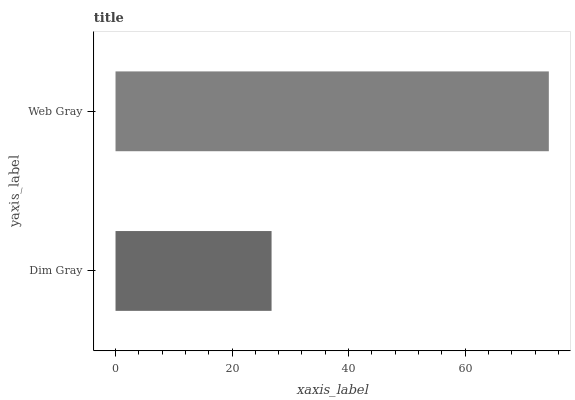Is Dim Gray the minimum?
Answer yes or no. Yes. Is Web Gray the maximum?
Answer yes or no. Yes. Is Web Gray the minimum?
Answer yes or no. No. Is Web Gray greater than Dim Gray?
Answer yes or no. Yes. Is Dim Gray less than Web Gray?
Answer yes or no. Yes. Is Dim Gray greater than Web Gray?
Answer yes or no. No. Is Web Gray less than Dim Gray?
Answer yes or no. No. Is Web Gray the high median?
Answer yes or no. Yes. Is Dim Gray the low median?
Answer yes or no. Yes. Is Dim Gray the high median?
Answer yes or no. No. Is Web Gray the low median?
Answer yes or no. No. 